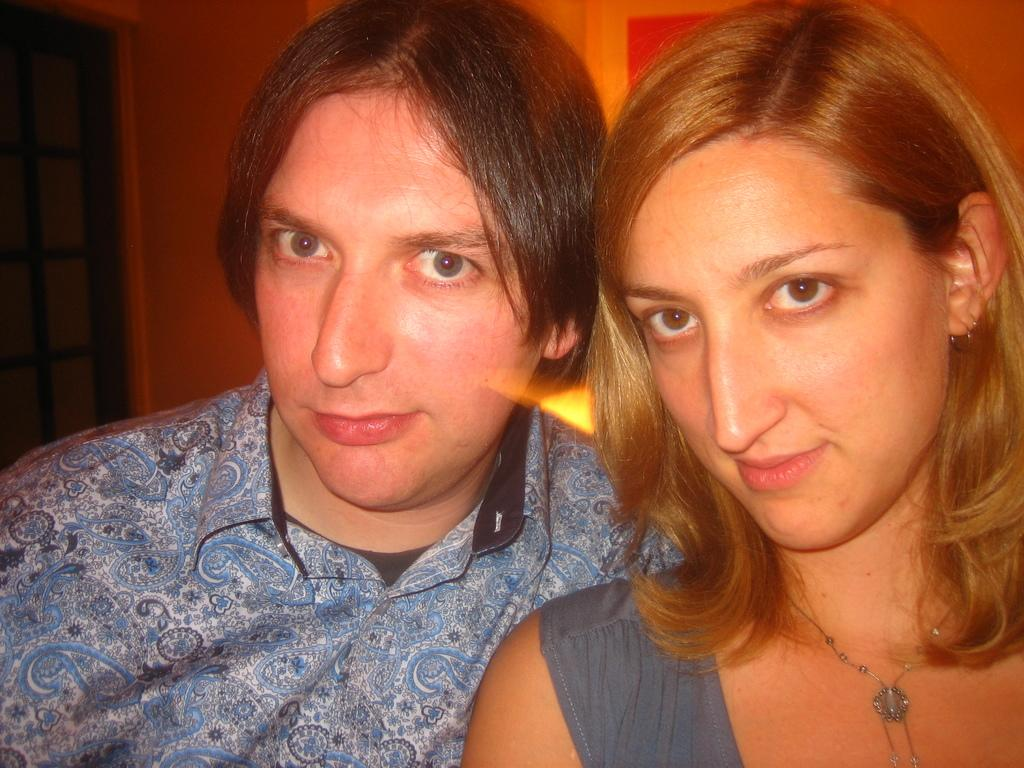How many people are in the image? There are two people in the image, a man and a woman. What are the expressions on their faces? Both the man and the woman are smiling in the image. What are they wearing? The man and the woman are wearing clothes. Can you describe any accessories the woman is wearing? The woman is wearing a neck chain and earrings. What can be seen in the background of the image? There is a fence and a wall in the image. What type of house is visible in the image? There is no house visible in the image; only a fence and a wall are present in the background. 